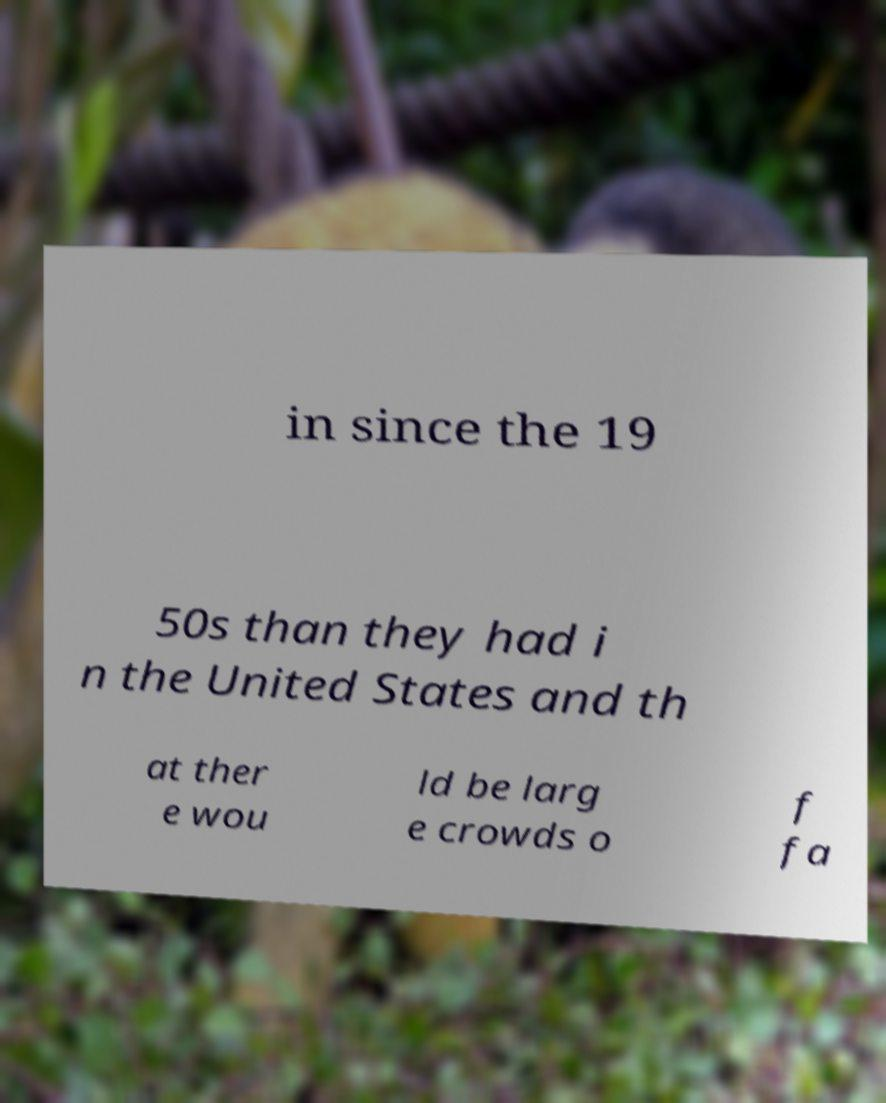Please read and relay the text visible in this image. What does it say? in since the 19 50s than they had i n the United States and th at ther e wou ld be larg e crowds o f fa 